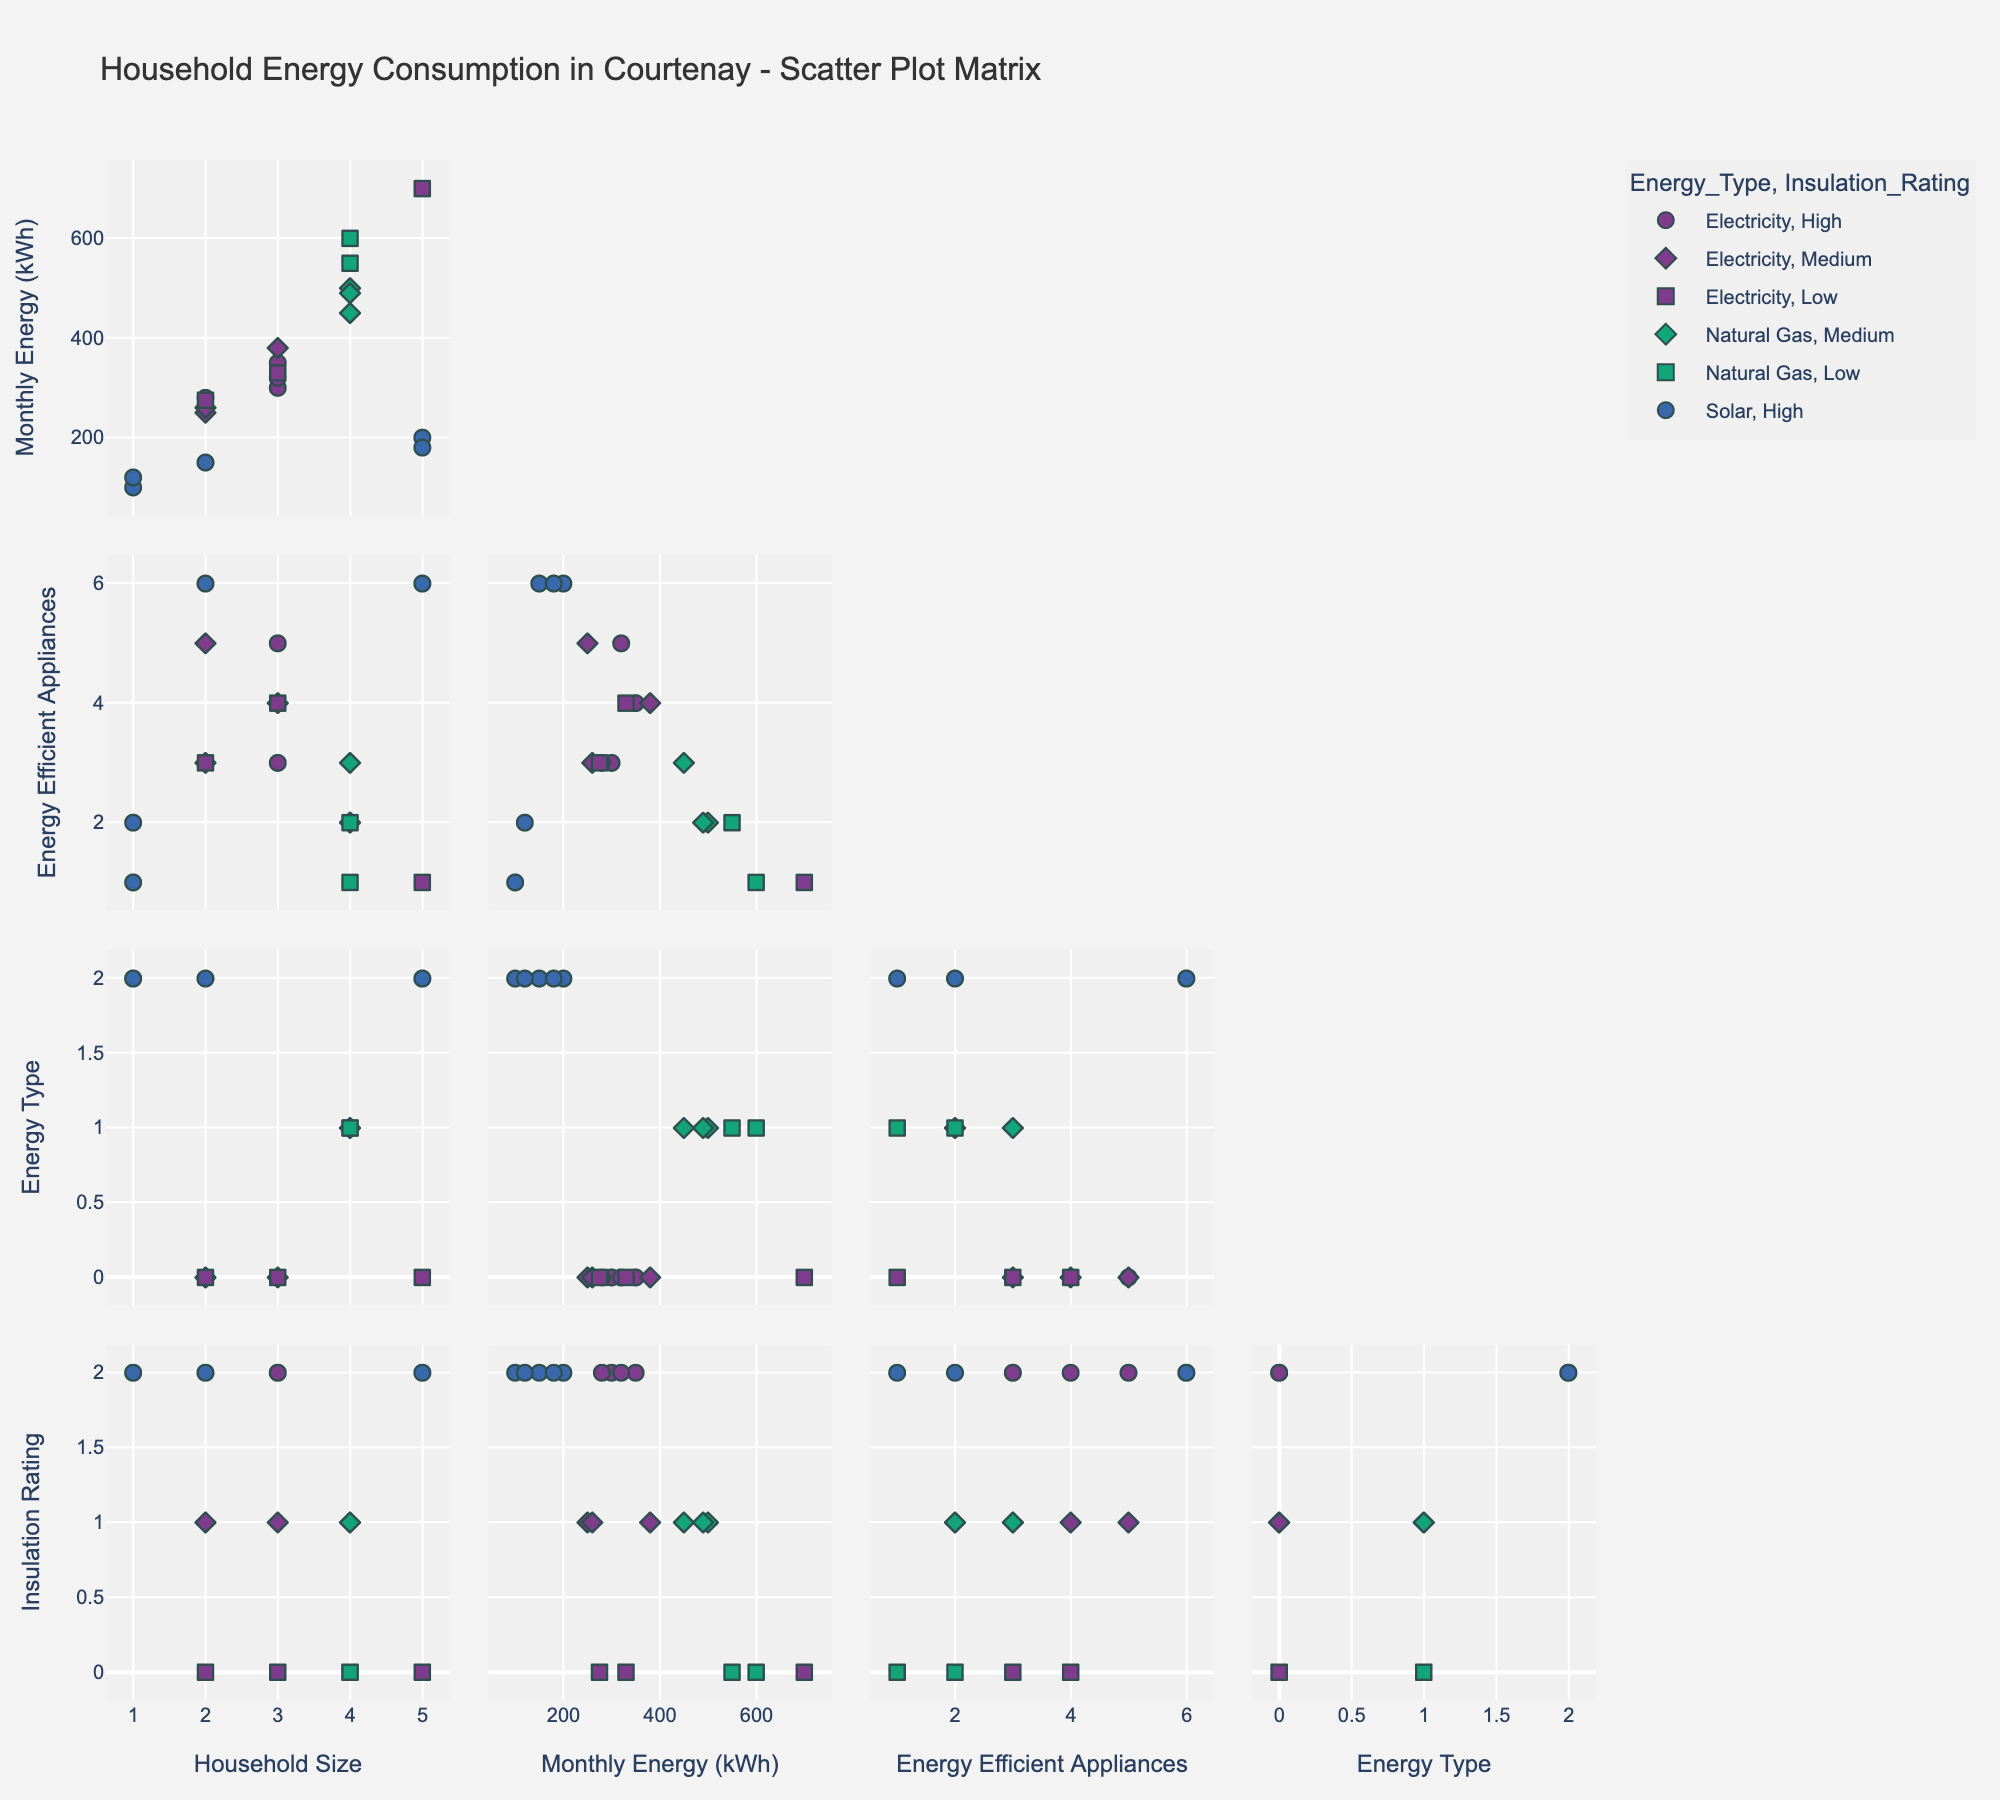What is the title of the scatter plot matrix? The title of the scatter plot matrix is displayed at the top of the figure.
Answer: Household Energy Consumption in Courtenay - Scatter Plot Matrix How are the different energy types represented in the scatter plot matrix? Different energy types are represented using different colors, which can be observed by looking at the color legend on the figure.
Answer: By color Which insulation rating symbol appears the most frequently in the scatter plot matrix? The most frequent insulation rating symbol can be identified by observing the plotted symbols in the scatter plot matrix.
Answer: Circle What is the general relationship between household size and monthly energy consumption? By examining the scatter plot for the variables "Household Size" and "Monthly Energy (kWh)", the direction and spread of data points can be determined to identify any trend.
Answer: Generally, as household size increases, monthly energy consumption increases Which energy type tends to have the highest number of energy-efficient appliances? Look at the distribution of points along the "Energy Efficient Appliances" axis for different energy types. Identify which colored points are more numerous at the higher appliance values.
Answer: Solar Does the insulation rating seem to influence the monthly energy consumption? Check the scatter plots where "Insulation Rating" symbols overlay with "Monthly Energy (kWh)" values for each data point to identify if there's a distinct pattern for different insulation ratings.
Answer: Higher insulation ratings generally correlate with lower monthly energy consumption Which combination of energy type and insulation rating has the highest energy consumption? Observe the highest data points in the "Monthly Energy (kWh)" scatter plots, then look at their corresponding symbols and colors to identify energy type and insulation rating combinations.
Answer: Natural Gas with Low insulation rating On average, do households with medium insulation rating consume more or less energy-efficient appliances compared to high insulation ratings? Compare the distribution of points on the "Energy Efficient Appliances" axis for both medium and high insulation ratings by looking at their respective symbol shapes.
Answer: Less Is there any clear pattern between household size and the number of energy-efficient appliances? Examine the scatter plot that displays "Household Size" on one axis and "Energy Efficient Appliances" on the other to detect any discernible trend or pattern between the two variables.
Answer: No clear pattern Which energy type has the least variation in monthly energy consumption? Assess the spread of points in the scatter plot matrix for different energy types along the "Monthly Energy (kWh)" axis to determine which one has the least variation.
Answer: Solar 